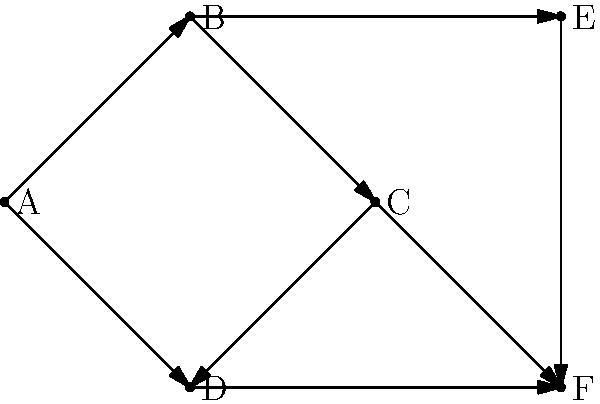As a newly promoted team leader, you're analyzing the communication flow within your team using the network diagram above. Each node represents a team member, and each directed edge represents a communication channel. What is the minimum number of team members you need to directly communicate with to ensure that information can flow to all team members? To solve this problem, we need to find the minimum number of vertices that, when selected, allow us to reach all other vertices in the directed graph. This is known as the minimum dominating set problem in graph theory.

Let's approach this step-by-step:

1) First, observe that node A has only outgoing edges, so it must receive information from another node.

2) Node B can reach nodes A, C, and E directly or indirectly.

3) Node C can reach nodes D and F.

4) Node D can only reach F.

5) Nodes E and F have no outgoing edges, so they must receive information from other nodes.

6) The key is to find the nodes that can reach the most other nodes:
   - B can reach A, C, E, and indirectly D and F (through C).
   - C can reach D and F directly.

7) By selecting B and C, we can ensure that information flows to all team members:
   - B → A, E
   - B → C → D, F

Therefore, the minimum number of team members you need to directly communicate with is 2 (B and C).

This solution ensures that information can flow to all team members while minimizing the number of direct communications you need to make as a team leader.
Answer: 2 (nodes B and C) 